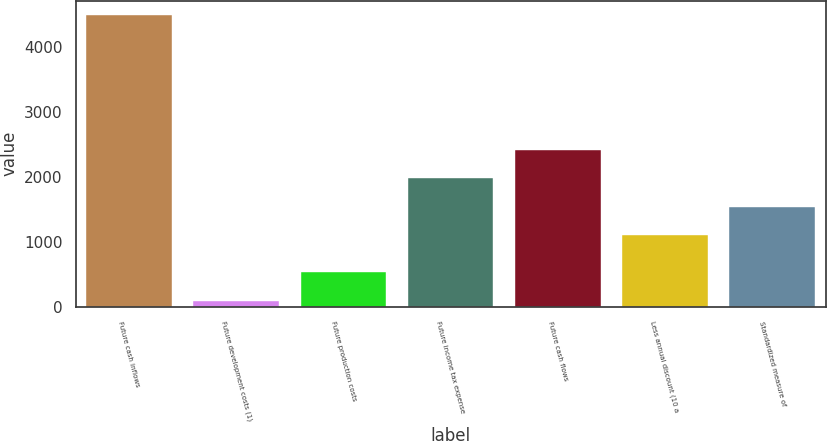Convert chart to OTSL. <chart><loc_0><loc_0><loc_500><loc_500><bar_chart><fcel>Future cash inflows<fcel>Future development costs (1)<fcel>Future production costs<fcel>Future income tax expense<fcel>Future cash flows<fcel>Less annual discount (10 a<fcel>Standardized measure of<nl><fcel>4485<fcel>98<fcel>536.7<fcel>1978.4<fcel>2417.1<fcel>1101<fcel>1539.7<nl></chart> 